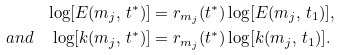<formula> <loc_0><loc_0><loc_500><loc_500>\log [ E ( m _ { j } , \, t ^ { \ast } ) ] & = r _ { m _ { j } } ( t ^ { \ast } ) \log [ E ( m _ { j } , \, t _ { 1 } ) ] , \\ a n d \quad \log [ k ( m _ { j } , \, t ^ { \ast } ) ] & = r _ { m _ { j } } ( t ^ { \ast } ) \log [ k ( m _ { j } , \, t _ { 1 } ) ] .</formula> 